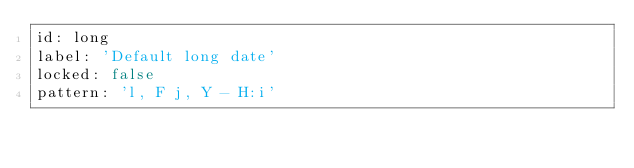Convert code to text. <code><loc_0><loc_0><loc_500><loc_500><_YAML_>id: long
label: 'Default long date'
locked: false
pattern: 'l, F j, Y - H:i'
</code> 